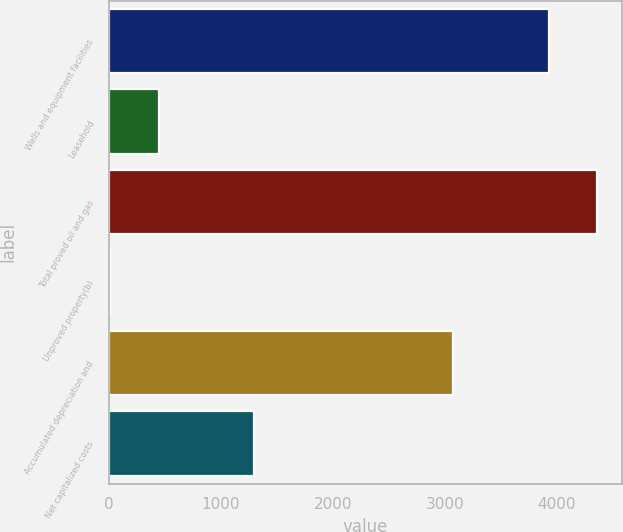Convert chart. <chart><loc_0><loc_0><loc_500><loc_500><bar_chart><fcel>Wells and equipment facilities<fcel>Leasehold<fcel>Total proved oil and gas<fcel>Unproved property(b)<fcel>Accumulated depreciation and<fcel>Net capitalized costs<nl><fcel>3927<fcel>442.7<fcel>4361.7<fcel>8<fcel>3072<fcel>1291<nl></chart> 